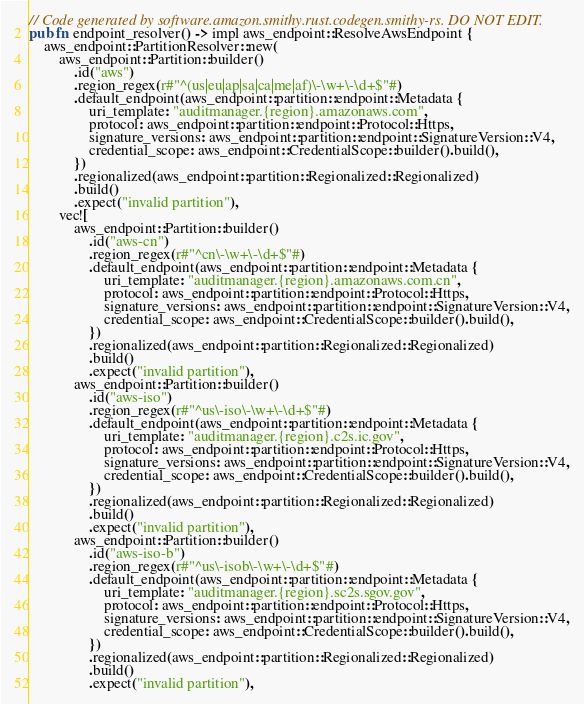<code> <loc_0><loc_0><loc_500><loc_500><_Rust_>// Code generated by software.amazon.smithy.rust.codegen.smithy-rs. DO NOT EDIT.
pub fn endpoint_resolver() -> impl aws_endpoint::ResolveAwsEndpoint {
    aws_endpoint::PartitionResolver::new(
        aws_endpoint::Partition::builder()
            .id("aws")
            .region_regex(r#"^(us|eu|ap|sa|ca|me|af)\-\w+\-\d+$"#)
            .default_endpoint(aws_endpoint::partition::endpoint::Metadata {
                uri_template: "auditmanager.{region}.amazonaws.com",
                protocol: aws_endpoint::partition::endpoint::Protocol::Https,
                signature_versions: aws_endpoint::partition::endpoint::SignatureVersion::V4,
                credential_scope: aws_endpoint::CredentialScope::builder().build(),
            })
            .regionalized(aws_endpoint::partition::Regionalized::Regionalized)
            .build()
            .expect("invalid partition"),
        vec![
            aws_endpoint::Partition::builder()
                .id("aws-cn")
                .region_regex(r#"^cn\-\w+\-\d+$"#)
                .default_endpoint(aws_endpoint::partition::endpoint::Metadata {
                    uri_template: "auditmanager.{region}.amazonaws.com.cn",
                    protocol: aws_endpoint::partition::endpoint::Protocol::Https,
                    signature_versions: aws_endpoint::partition::endpoint::SignatureVersion::V4,
                    credential_scope: aws_endpoint::CredentialScope::builder().build(),
                })
                .regionalized(aws_endpoint::partition::Regionalized::Regionalized)
                .build()
                .expect("invalid partition"),
            aws_endpoint::Partition::builder()
                .id("aws-iso")
                .region_regex(r#"^us\-iso\-\w+\-\d+$"#)
                .default_endpoint(aws_endpoint::partition::endpoint::Metadata {
                    uri_template: "auditmanager.{region}.c2s.ic.gov",
                    protocol: aws_endpoint::partition::endpoint::Protocol::Https,
                    signature_versions: aws_endpoint::partition::endpoint::SignatureVersion::V4,
                    credential_scope: aws_endpoint::CredentialScope::builder().build(),
                })
                .regionalized(aws_endpoint::partition::Regionalized::Regionalized)
                .build()
                .expect("invalid partition"),
            aws_endpoint::Partition::builder()
                .id("aws-iso-b")
                .region_regex(r#"^us\-isob\-\w+\-\d+$"#)
                .default_endpoint(aws_endpoint::partition::endpoint::Metadata {
                    uri_template: "auditmanager.{region}.sc2s.sgov.gov",
                    protocol: aws_endpoint::partition::endpoint::Protocol::Https,
                    signature_versions: aws_endpoint::partition::endpoint::SignatureVersion::V4,
                    credential_scope: aws_endpoint::CredentialScope::builder().build(),
                })
                .regionalized(aws_endpoint::partition::Regionalized::Regionalized)
                .build()
                .expect("invalid partition"),</code> 